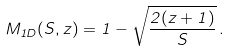<formula> <loc_0><loc_0><loc_500><loc_500>M _ { 1 D } ( S , z ) = 1 - \sqrt { \frac { 2 ( z + 1 ) } { S } } \, .</formula> 